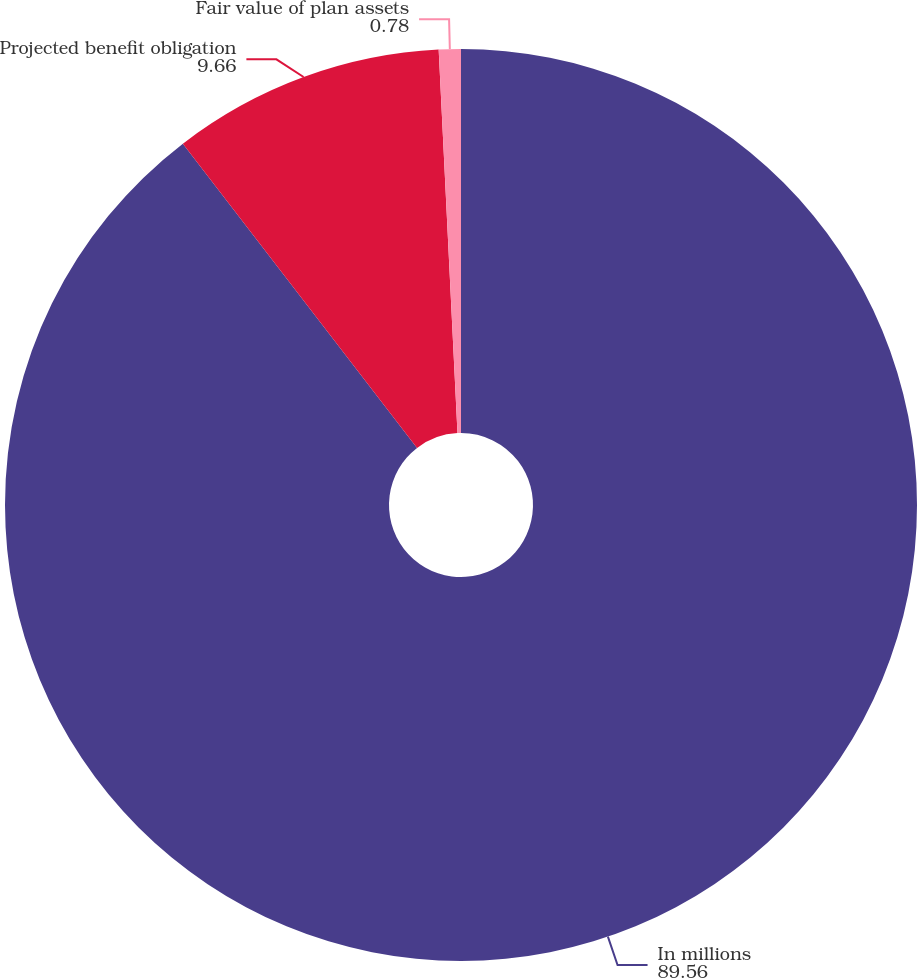Convert chart. <chart><loc_0><loc_0><loc_500><loc_500><pie_chart><fcel>In millions<fcel>Projected benefit obligation<fcel>Fair value of plan assets<nl><fcel>89.56%<fcel>9.66%<fcel>0.78%<nl></chart> 